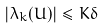Convert formula to latex. <formula><loc_0><loc_0><loc_500><loc_500>| \lambda _ { k } ( U ) | \leq K \delta</formula> 